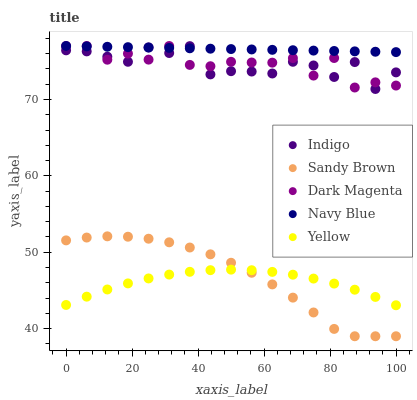Does Yellow have the minimum area under the curve?
Answer yes or no. Yes. Does Navy Blue have the maximum area under the curve?
Answer yes or no. Yes. Does Indigo have the minimum area under the curve?
Answer yes or no. No. Does Indigo have the maximum area under the curve?
Answer yes or no. No. Is Navy Blue the smoothest?
Answer yes or no. Yes. Is Dark Magenta the roughest?
Answer yes or no. Yes. Is Indigo the smoothest?
Answer yes or no. No. Is Indigo the roughest?
Answer yes or no. No. Does Sandy Brown have the lowest value?
Answer yes or no. Yes. Does Indigo have the lowest value?
Answer yes or no. No. Does Navy Blue have the highest value?
Answer yes or no. Yes. Does Indigo have the highest value?
Answer yes or no. No. Is Yellow less than Indigo?
Answer yes or no. Yes. Is Navy Blue greater than Yellow?
Answer yes or no. Yes. Does Sandy Brown intersect Yellow?
Answer yes or no. Yes. Is Sandy Brown less than Yellow?
Answer yes or no. No. Is Sandy Brown greater than Yellow?
Answer yes or no. No. Does Yellow intersect Indigo?
Answer yes or no. No. 